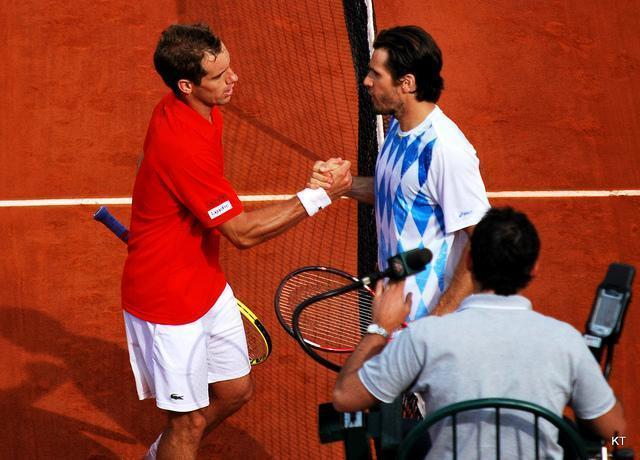How many people are in the picture?
Give a very brief answer. 3. 